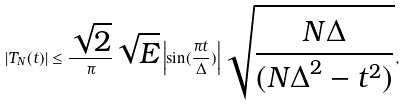<formula> <loc_0><loc_0><loc_500><loc_500>| T _ { N } ( t ) | \leq \frac { \sqrt { 2 } } { \pi } \sqrt { E } \left | \sin ( \frac { \pi t } { \Delta } ) \right | \sqrt { \frac { N \Delta } { ( { N \Delta } ^ { 2 } - t ^ { 2 } ) } } ,</formula> 